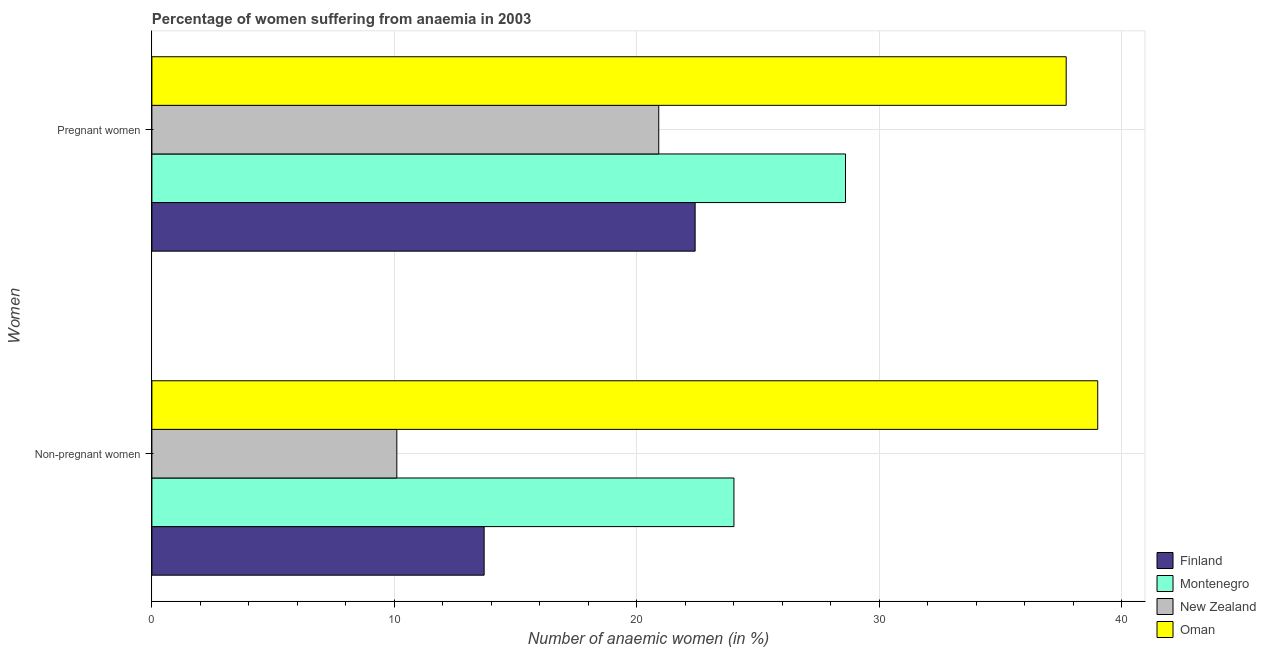How many groups of bars are there?
Offer a very short reply. 2. How many bars are there on the 1st tick from the bottom?
Ensure brevity in your answer.  4. What is the label of the 1st group of bars from the top?
Ensure brevity in your answer.  Pregnant women. In which country was the percentage of non-pregnant anaemic women maximum?
Make the answer very short. Oman. In which country was the percentage of non-pregnant anaemic women minimum?
Offer a terse response. New Zealand. What is the total percentage of non-pregnant anaemic women in the graph?
Your answer should be very brief. 86.8. What is the difference between the percentage of pregnant anaemic women in Oman and that in Montenegro?
Offer a terse response. 9.1. What is the difference between the percentage of non-pregnant anaemic women in Montenegro and the percentage of pregnant anaemic women in Finland?
Your answer should be compact. 1.6. What is the average percentage of pregnant anaemic women per country?
Your response must be concise. 27.4. What is the ratio of the percentage of pregnant anaemic women in Finland to that in Oman?
Provide a short and direct response. 0.59. Is the percentage of pregnant anaemic women in Montenegro less than that in New Zealand?
Your answer should be compact. No. In how many countries, is the percentage of non-pregnant anaemic women greater than the average percentage of non-pregnant anaemic women taken over all countries?
Offer a terse response. 2. What does the 1st bar from the top in Non-pregnant women represents?
Keep it short and to the point. Oman. What does the 2nd bar from the bottom in Pregnant women represents?
Offer a very short reply. Montenegro. How many bars are there?
Make the answer very short. 8. How many countries are there in the graph?
Offer a terse response. 4. Does the graph contain any zero values?
Keep it short and to the point. No. Does the graph contain grids?
Your answer should be compact. Yes. Where does the legend appear in the graph?
Give a very brief answer. Bottom right. How many legend labels are there?
Give a very brief answer. 4. What is the title of the graph?
Give a very brief answer. Percentage of women suffering from anaemia in 2003. What is the label or title of the X-axis?
Make the answer very short. Number of anaemic women (in %). What is the label or title of the Y-axis?
Offer a terse response. Women. What is the Number of anaemic women (in %) of Finland in Non-pregnant women?
Your response must be concise. 13.7. What is the Number of anaemic women (in %) of Montenegro in Non-pregnant women?
Your answer should be compact. 24. What is the Number of anaemic women (in %) of New Zealand in Non-pregnant women?
Provide a short and direct response. 10.1. What is the Number of anaemic women (in %) in Finland in Pregnant women?
Provide a succinct answer. 22.4. What is the Number of anaemic women (in %) in Montenegro in Pregnant women?
Your answer should be compact. 28.6. What is the Number of anaemic women (in %) of New Zealand in Pregnant women?
Offer a very short reply. 20.9. What is the Number of anaemic women (in %) in Oman in Pregnant women?
Offer a very short reply. 37.7. Across all Women, what is the maximum Number of anaemic women (in %) in Finland?
Provide a succinct answer. 22.4. Across all Women, what is the maximum Number of anaemic women (in %) of Montenegro?
Provide a succinct answer. 28.6. Across all Women, what is the maximum Number of anaemic women (in %) in New Zealand?
Ensure brevity in your answer.  20.9. Across all Women, what is the maximum Number of anaemic women (in %) of Oman?
Your answer should be compact. 39. Across all Women, what is the minimum Number of anaemic women (in %) of Montenegro?
Provide a short and direct response. 24. Across all Women, what is the minimum Number of anaemic women (in %) of Oman?
Your answer should be very brief. 37.7. What is the total Number of anaemic women (in %) of Finland in the graph?
Your answer should be compact. 36.1. What is the total Number of anaemic women (in %) of Montenegro in the graph?
Give a very brief answer. 52.6. What is the total Number of anaemic women (in %) in Oman in the graph?
Your answer should be compact. 76.7. What is the difference between the Number of anaemic women (in %) of Montenegro in Non-pregnant women and that in Pregnant women?
Give a very brief answer. -4.6. What is the difference between the Number of anaemic women (in %) of Finland in Non-pregnant women and the Number of anaemic women (in %) of Montenegro in Pregnant women?
Ensure brevity in your answer.  -14.9. What is the difference between the Number of anaemic women (in %) in Finland in Non-pregnant women and the Number of anaemic women (in %) in Oman in Pregnant women?
Your answer should be compact. -24. What is the difference between the Number of anaemic women (in %) in Montenegro in Non-pregnant women and the Number of anaemic women (in %) in Oman in Pregnant women?
Provide a short and direct response. -13.7. What is the difference between the Number of anaemic women (in %) in New Zealand in Non-pregnant women and the Number of anaemic women (in %) in Oman in Pregnant women?
Make the answer very short. -27.6. What is the average Number of anaemic women (in %) of Finland per Women?
Ensure brevity in your answer.  18.05. What is the average Number of anaemic women (in %) of Montenegro per Women?
Give a very brief answer. 26.3. What is the average Number of anaemic women (in %) of Oman per Women?
Your response must be concise. 38.35. What is the difference between the Number of anaemic women (in %) of Finland and Number of anaemic women (in %) of Oman in Non-pregnant women?
Make the answer very short. -25.3. What is the difference between the Number of anaemic women (in %) of Montenegro and Number of anaemic women (in %) of New Zealand in Non-pregnant women?
Keep it short and to the point. 13.9. What is the difference between the Number of anaemic women (in %) in New Zealand and Number of anaemic women (in %) in Oman in Non-pregnant women?
Your response must be concise. -28.9. What is the difference between the Number of anaemic women (in %) in Finland and Number of anaemic women (in %) in New Zealand in Pregnant women?
Your answer should be compact. 1.5. What is the difference between the Number of anaemic women (in %) of Finland and Number of anaemic women (in %) of Oman in Pregnant women?
Make the answer very short. -15.3. What is the difference between the Number of anaemic women (in %) in Montenegro and Number of anaemic women (in %) in New Zealand in Pregnant women?
Provide a succinct answer. 7.7. What is the difference between the Number of anaemic women (in %) of Montenegro and Number of anaemic women (in %) of Oman in Pregnant women?
Make the answer very short. -9.1. What is the difference between the Number of anaemic women (in %) in New Zealand and Number of anaemic women (in %) in Oman in Pregnant women?
Ensure brevity in your answer.  -16.8. What is the ratio of the Number of anaemic women (in %) in Finland in Non-pregnant women to that in Pregnant women?
Your response must be concise. 0.61. What is the ratio of the Number of anaemic women (in %) in Montenegro in Non-pregnant women to that in Pregnant women?
Make the answer very short. 0.84. What is the ratio of the Number of anaemic women (in %) of New Zealand in Non-pregnant women to that in Pregnant women?
Give a very brief answer. 0.48. What is the ratio of the Number of anaemic women (in %) of Oman in Non-pregnant women to that in Pregnant women?
Keep it short and to the point. 1.03. What is the difference between the highest and the second highest Number of anaemic women (in %) in Montenegro?
Your answer should be compact. 4.6. What is the difference between the highest and the second highest Number of anaemic women (in %) in New Zealand?
Provide a short and direct response. 10.8. What is the difference between the highest and the second highest Number of anaemic women (in %) in Oman?
Make the answer very short. 1.3. What is the difference between the highest and the lowest Number of anaemic women (in %) in Finland?
Make the answer very short. 8.7. What is the difference between the highest and the lowest Number of anaemic women (in %) of New Zealand?
Provide a short and direct response. 10.8. 